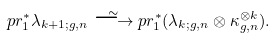Convert formula to latex. <formula><loc_0><loc_0><loc_500><loc_500>p r _ { 1 } ^ { \ast } \lambda _ { k + 1 ; g , n } \overset { \sim } { \longrightarrow } p r _ { 1 } ^ { \ast } ( \lambda _ { k ; g , n } \otimes \kappa _ { g , n } ^ { \otimes k } ) .</formula> 